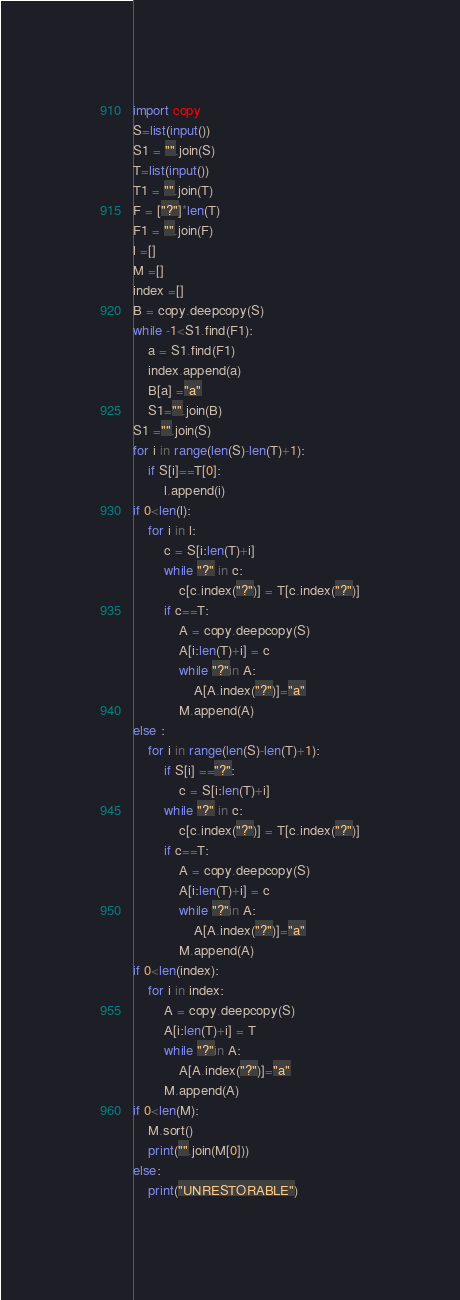Convert code to text. <code><loc_0><loc_0><loc_500><loc_500><_Python_>import copy
S=list(input())
S1 = "".join(S)
T=list(input())
T1 = "".join(T)
F = ["?"]*len(T)
F1 = "".join(F)
l =[]
M =[]
index =[]
B = copy.deepcopy(S)
while -1<S1.find(F1):
    a = S1.find(F1)
    index.append(a)
    B[a] ="a"
    S1="".join(B)
S1 ="".join(S)
for i in range(len(S)-len(T)+1):
    if S[i]==T[0]:
        l.append(i)
if 0<len(l):
    for i in l:
        c = S[i:len(T)+i]
        while "?" in c:
            c[c.index("?")] = T[c.index("?")]
        if c==T:
            A = copy.deepcopy(S)
            A[i:len(T)+i] = c
            while "?"in A:
                A[A.index("?")]="a"
            M.append(A)
else :
    for i in range(len(S)-len(T)+1):
        if S[i] =="?":
            c = S[i:len(T)+i]
        while "?" in c:
            c[c.index("?")] = T[c.index("?")]
        if c==T:
            A = copy.deepcopy(S)
            A[i:len(T)+i] = c
            while "?"in A:
                A[A.index("?")]="a"
            M.append(A)
if 0<len(index):
    for i in index:
        A = copy.deepcopy(S)
        A[i:len(T)+i] = T
        while "?"in A:
            A[A.index("?")]="a"
        M.append(A)
if 0<len(M):
    M.sort()
    print("".join(M[0]))
else:
    print("UNRESTORABLE")</code> 